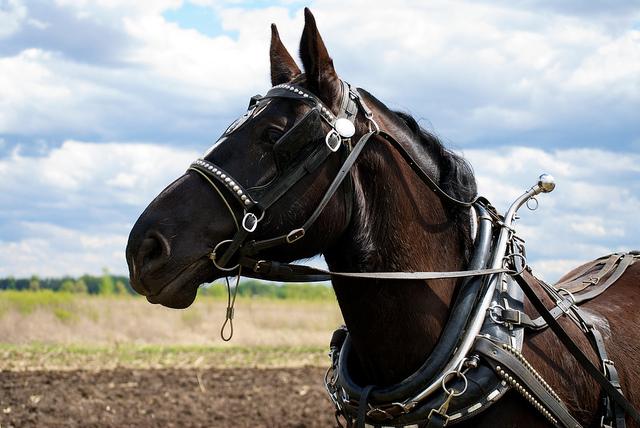What's on the horses back?
Answer briefly. Saddle. Where is a bent nail?
Concise answer only. Nowhere. Is this horse real?
Short answer required. Yes. What is around the horse's neck?
Quick response, please. Harness. What color is the horse?
Short answer required. Brown. What is the color of the horse?
Answer briefly. Brown. 